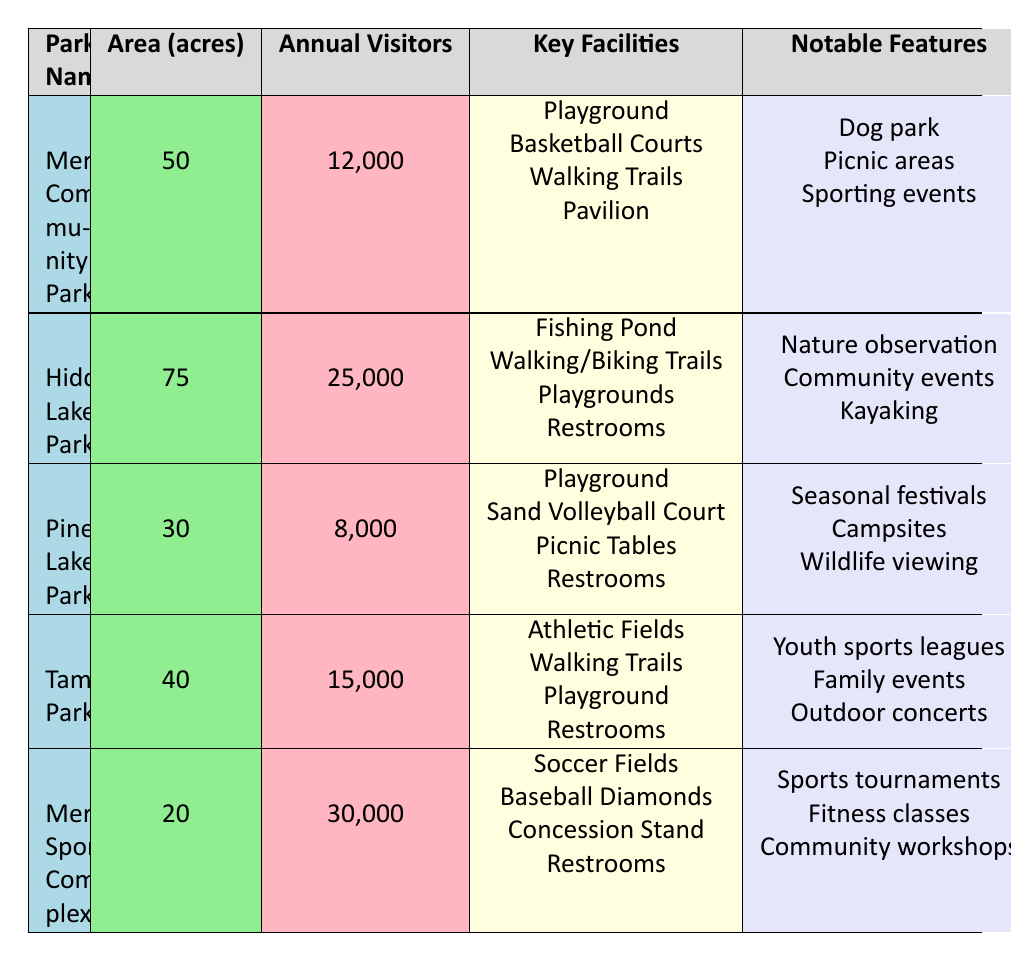What is the total area of all the parks listed? The areas of each park are as follows: 50 acres (Merrillville Community Park), 75 acres (Hidden Lake Park), 30 acres (Pine Lake Park), 40 acres (Tamarack Park), and 20 acres (Merrillville Sports Complex). Summing these gives 50 + 75 + 30 + 40 + 20 = 215 acres.
Answer: 215 acres How many annual visitors does the Merrillville Sports Complex have? The table lists the annual visitors for each park. For Merrillville Sports Complex, the annual visitors are indicated as 30,000.
Answer: 30,000 Which park has the highest number of annual visitors? By comparing the annual visitor counts, Merrillville Sports Complex has 30,000 visitors, Hidden Lake Park has 25,000 visitors, Tamarack Park has 15,000 visitors, Merrillville Community Park has 12,000 visitors, and Pine Lake Park has 8,000 visitors. The highest count is 30,000 at the Merrillville Sports Complex.
Answer: Merrillville Sports Complex Does Pine Lake Park offer a dog park? The features of Pine Lake Park include seasonal festivals, campsites, and wildlife viewing. There is no mention of a dog park in the features listed, indicating that this park does not offer a dog park.
Answer: No What is the average number of annual visitors across all parks? To find the average, we first sum the annual visitors: 12,000 (Merrillville Community Park) + 25,000 (Hidden Lake Park) + 8,000 (Pine Lake Park) + 15,000 (Tamarack Park) + 30,000 (Merrillville Sports Complex) = 90,000 visitors. Then, divide by the number of parks, which is 5. Therefore, the average is 90,000 / 5 = 18,000.
Answer: 18,000 Which park has the smallest area? Comparing the areas listed: Merrillville Community Park (50 acres), Hidden Lake Park (75 acres), Pine Lake Park (30 acres), Tamarack Park (40 acres), and Merrillville Sports Complex (20 acres). The smallest area is 20 acres at the Merrillville Sports Complex.
Answer: Merrillville Sports Complex Does Hidden Lake Park have restrooms? The facilities for Hidden Lake Park include a fishing pond, walking/biking trails, playgrounds, and restrooms. Since restrooms are listed as a facility, Hidden Lake Park does indeed have restrooms.
Answer: Yes How many parks feature walking trails? Walking trails are listed as a facility in the following parks: Merrillville Community Park, Hidden Lake Park, Tamarack Park. Counting these gives a total of 3 parks that have walking trails.
Answer: 3 parks 